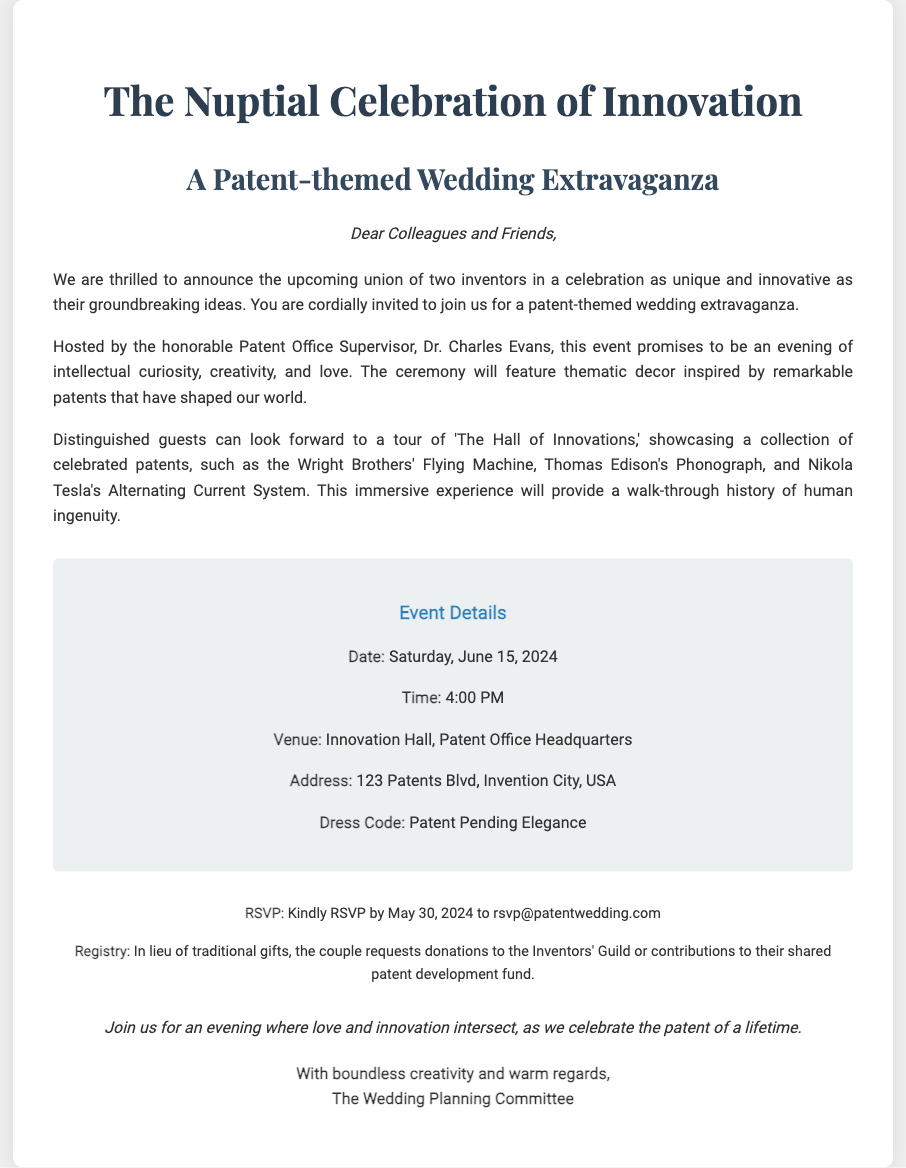What is the date of the wedding? The date of the wedding is clearly stated in the details section of the invitation.
Answer: Saturday, June 15, 2024 Who is hosting the event? The invitation mentions that Dr. Charles Evans is the host, which indicates his role in the celebration.
Answer: Dr. Charles Evans What is the dress code for the event? The dress code is highlighted in the event details, indicating the desired attire for guests.
Answer: Patent Pending Elegance Where is the wedding venue located? The venue is specified in the details section, providing the physical location for the event.
Answer: Innovation Hall, Patent Office Headquarters What should guests do if they want to attend? The RSVP information is provided in the additional info section, outlining the expected action for guests.
Answer: RSVP by May 30, 2024 What kind of experience will guests have at the wedding? The invitation describes an immersive experience showcasing celebrated patents, combining the theme of innovation with the event.
Answer: A tour of 'The Hall of Innovations' What type of contributions does the couple request? The registry section specifies the couple's preferences for contributions instead of traditional gifts, indicating their priorities.
Answer: Donations to the Inventors' Guild What is the title of the event? The title is prominently displayed at the top of the invitation, summarizing the theme of the celebration.
Answer: The Nuptial Celebration of Innovation How is the invitation signed off? The closing of the invitation provides insight into the sign-off format, reflecting the tone of the invitation.
Answer: With boundless creativity and warm regards, The Wedding Planning Committee 